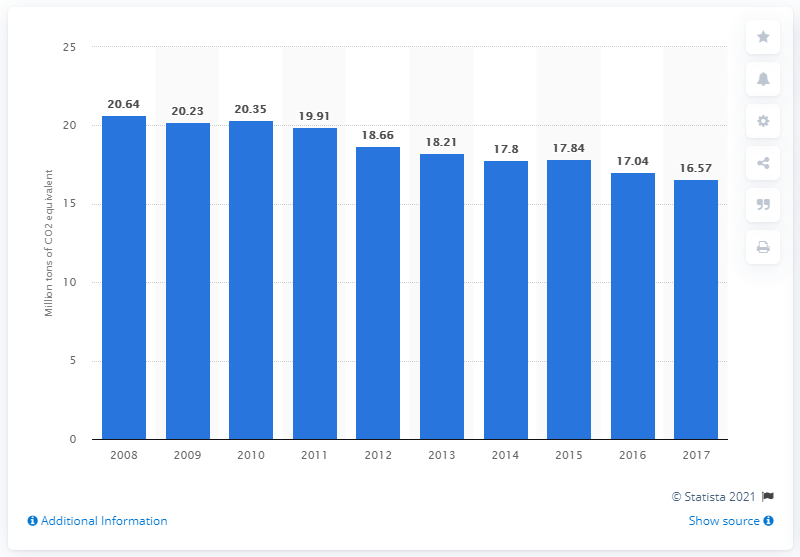Draw attention to some important aspects in this diagram. The combustion of fuel in Sweden in 2017 emitted a total of 16.57 units of CO2 equivalent. 